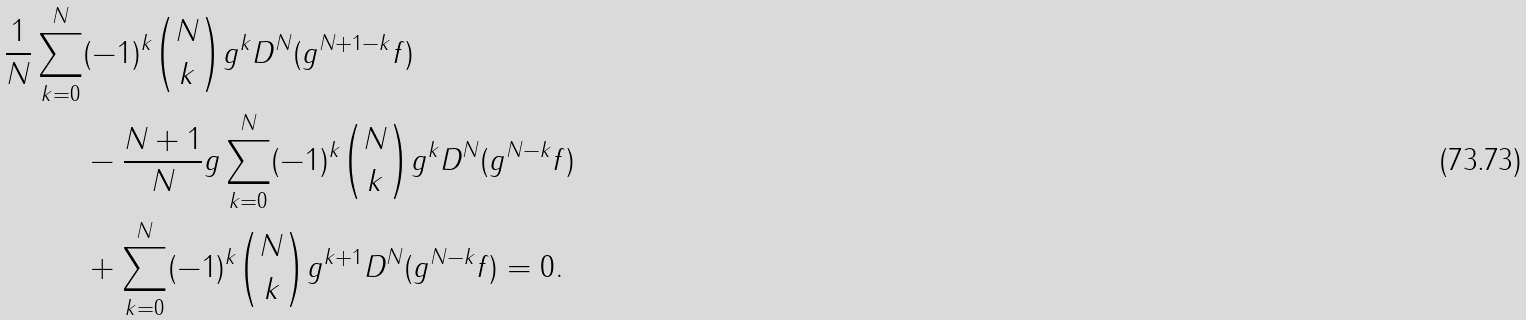<formula> <loc_0><loc_0><loc_500><loc_500>\frac { 1 } { N } \sum _ { k = 0 } ^ { N } & ( - 1 ) ^ { k } \binom { N } { k } g ^ { k } D ^ { N } ( g ^ { N + 1 - k } f ) \\ & - \frac { N + 1 } N g \sum _ { k = 0 } ^ { N } ( - 1 ) ^ { k } \binom { N } { k } g ^ { k } D ^ { N } ( g ^ { N - k } f ) \\ & + \sum _ { k = 0 } ^ { N } ( - 1 ) ^ { k } \binom { N } { k } g ^ { k + 1 } D ^ { N } ( g ^ { N - k } f ) = 0 .</formula> 